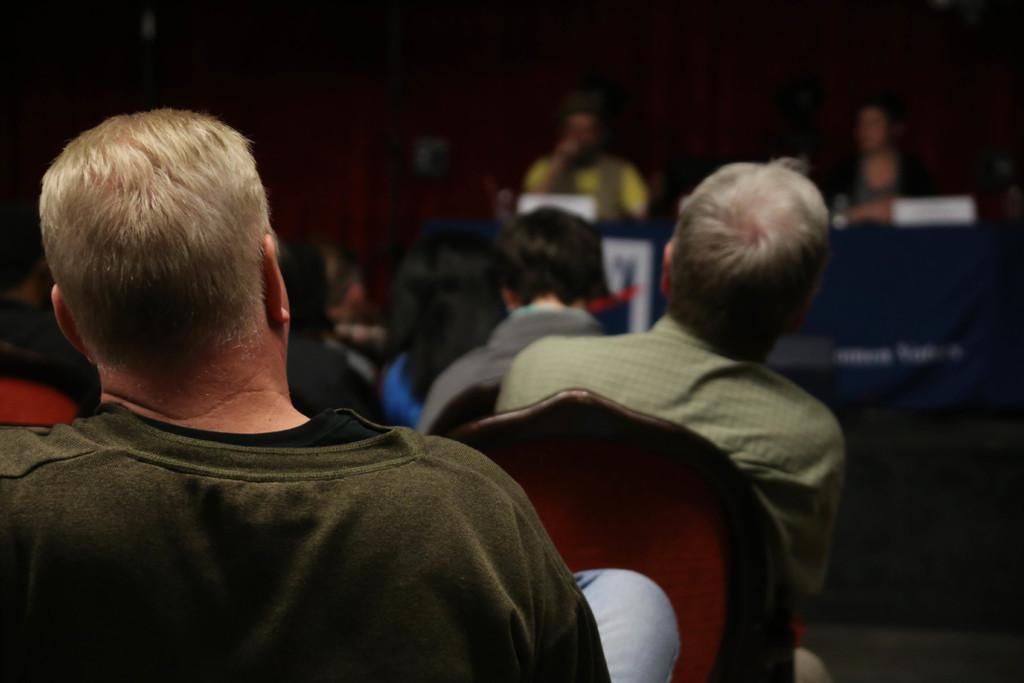Please provide a concise description of this image. In this image few persons are sitting on the chairs. Right side few persons are sitting behind the table having few objects on it. Behind them there is wall. 